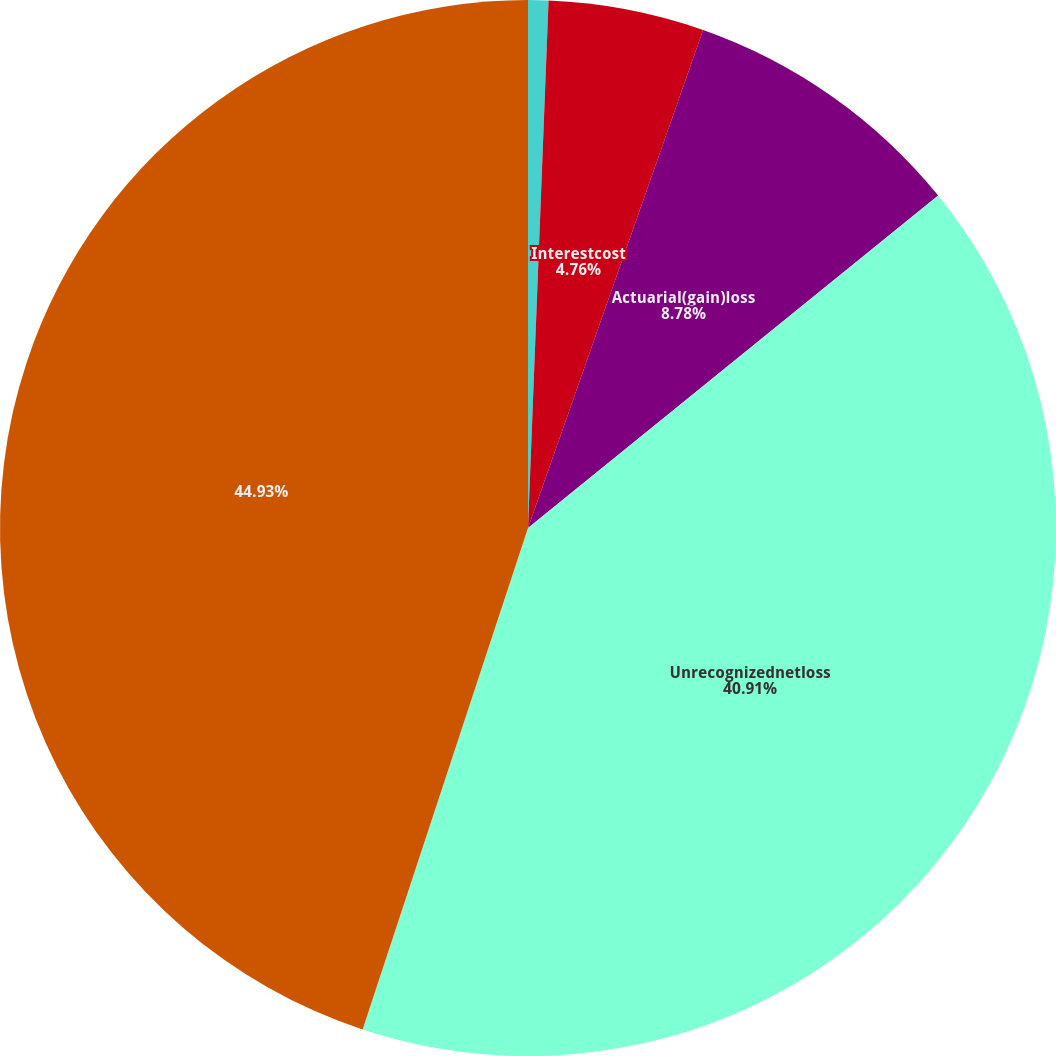Convert chart to OTSL. <chart><loc_0><loc_0><loc_500><loc_500><pie_chart><fcel>Servicecost<fcel>Interestcost<fcel>Actuarial(gain)loss<fcel>Unrecognizednetloss<fcel>Unnamed: 4<nl><fcel>0.62%<fcel>4.76%<fcel>8.78%<fcel>40.91%<fcel>44.93%<nl></chart> 